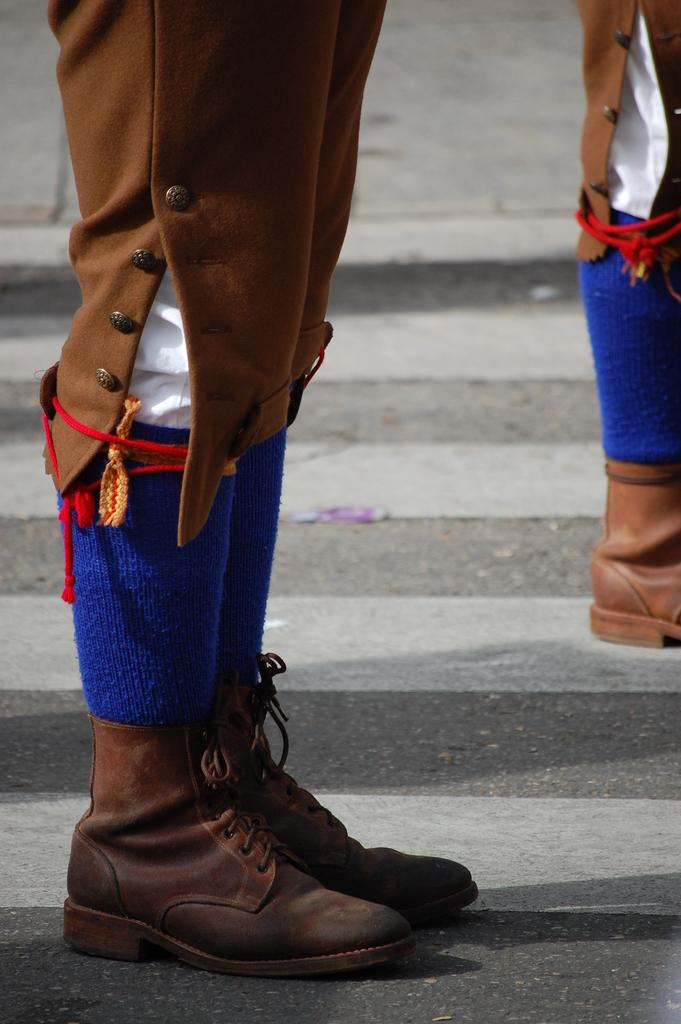What can be seen in the image that belongs to people? There are legs of people visible in the image. What can be seen on the road in the image? There are road safety markings on the road in the image. What type of carriage can be seen in the image? There is no carriage present in the image. How many clocks are visible in the image? There are no clocks visible in the image. 